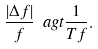<formula> <loc_0><loc_0><loc_500><loc_500>\frac { | \Delta f | } { f } \ a g t \frac { 1 } { T f } .</formula> 